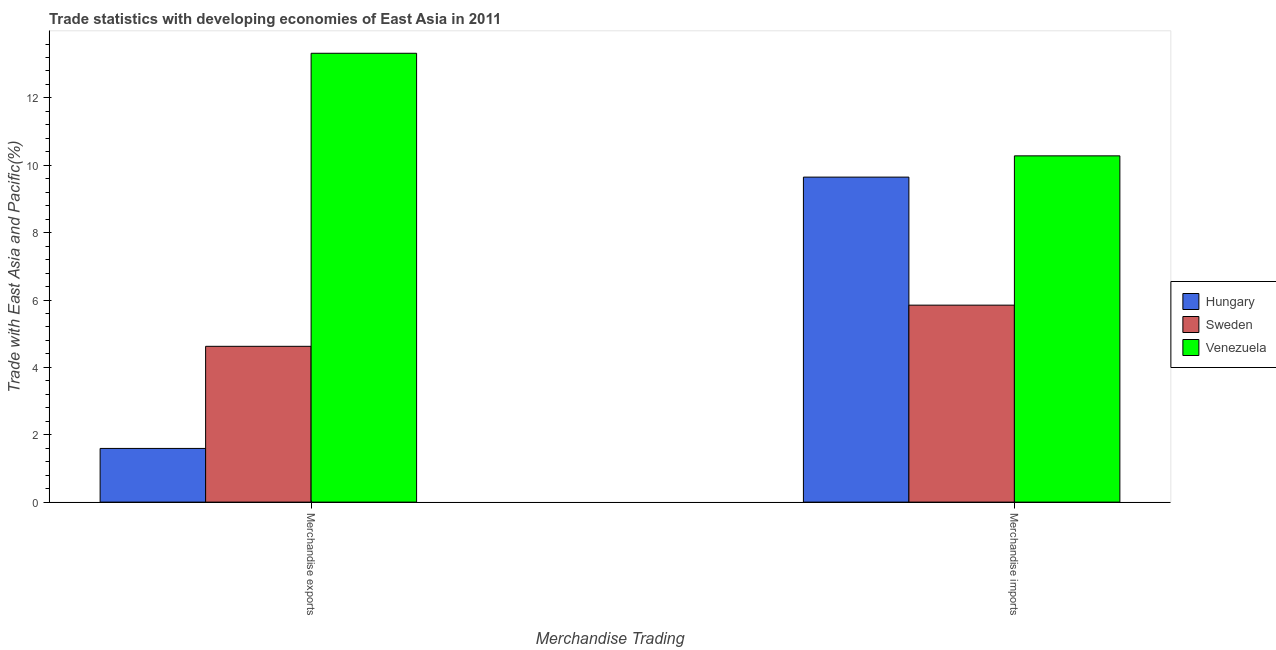How many different coloured bars are there?
Offer a very short reply. 3. Are the number of bars per tick equal to the number of legend labels?
Make the answer very short. Yes. Are the number of bars on each tick of the X-axis equal?
Offer a very short reply. Yes. How many bars are there on the 2nd tick from the left?
Offer a terse response. 3. What is the merchandise exports in Venezuela?
Provide a succinct answer. 13.33. Across all countries, what is the maximum merchandise imports?
Provide a short and direct response. 10.28. Across all countries, what is the minimum merchandise imports?
Provide a short and direct response. 5.85. In which country was the merchandise exports maximum?
Your answer should be compact. Venezuela. In which country was the merchandise exports minimum?
Provide a succinct answer. Hungary. What is the total merchandise exports in the graph?
Your answer should be very brief. 19.55. What is the difference between the merchandise exports in Sweden and that in Venezuela?
Offer a terse response. -8.7. What is the difference between the merchandise imports in Sweden and the merchandise exports in Hungary?
Offer a terse response. 4.25. What is the average merchandise imports per country?
Provide a short and direct response. 8.59. What is the difference between the merchandise exports and merchandise imports in Venezuela?
Give a very brief answer. 3.05. In how many countries, is the merchandise imports greater than 11.6 %?
Provide a short and direct response. 0. What is the ratio of the merchandise exports in Venezuela to that in Sweden?
Offer a terse response. 2.88. Is the merchandise imports in Sweden less than that in Hungary?
Your answer should be very brief. Yes. What does the 3rd bar from the left in Merchandise exports represents?
Your answer should be very brief. Venezuela. How many bars are there?
Give a very brief answer. 6. Are all the bars in the graph horizontal?
Offer a very short reply. No. How many countries are there in the graph?
Give a very brief answer. 3. What is the difference between two consecutive major ticks on the Y-axis?
Your answer should be very brief. 2. Are the values on the major ticks of Y-axis written in scientific E-notation?
Keep it short and to the point. No. Does the graph contain any zero values?
Give a very brief answer. No. Does the graph contain grids?
Provide a short and direct response. No. Where does the legend appear in the graph?
Your answer should be very brief. Center right. What is the title of the graph?
Offer a very short reply. Trade statistics with developing economies of East Asia in 2011. Does "Hungary" appear as one of the legend labels in the graph?
Make the answer very short. Yes. What is the label or title of the X-axis?
Give a very brief answer. Merchandise Trading. What is the label or title of the Y-axis?
Provide a succinct answer. Trade with East Asia and Pacific(%). What is the Trade with East Asia and Pacific(%) in Hungary in Merchandise exports?
Provide a short and direct response. 1.59. What is the Trade with East Asia and Pacific(%) in Sweden in Merchandise exports?
Your answer should be very brief. 4.63. What is the Trade with East Asia and Pacific(%) of Venezuela in Merchandise exports?
Offer a very short reply. 13.33. What is the Trade with East Asia and Pacific(%) of Hungary in Merchandise imports?
Ensure brevity in your answer.  9.65. What is the Trade with East Asia and Pacific(%) of Sweden in Merchandise imports?
Your answer should be very brief. 5.85. What is the Trade with East Asia and Pacific(%) of Venezuela in Merchandise imports?
Provide a short and direct response. 10.28. Across all Merchandise Trading, what is the maximum Trade with East Asia and Pacific(%) in Hungary?
Make the answer very short. 9.65. Across all Merchandise Trading, what is the maximum Trade with East Asia and Pacific(%) of Sweden?
Provide a succinct answer. 5.85. Across all Merchandise Trading, what is the maximum Trade with East Asia and Pacific(%) in Venezuela?
Your answer should be compact. 13.33. Across all Merchandise Trading, what is the minimum Trade with East Asia and Pacific(%) of Hungary?
Ensure brevity in your answer.  1.59. Across all Merchandise Trading, what is the minimum Trade with East Asia and Pacific(%) in Sweden?
Provide a short and direct response. 4.63. Across all Merchandise Trading, what is the minimum Trade with East Asia and Pacific(%) in Venezuela?
Your answer should be compact. 10.28. What is the total Trade with East Asia and Pacific(%) in Hungary in the graph?
Give a very brief answer. 11.24. What is the total Trade with East Asia and Pacific(%) in Sweden in the graph?
Provide a succinct answer. 10.47. What is the total Trade with East Asia and Pacific(%) of Venezuela in the graph?
Provide a succinct answer. 23.61. What is the difference between the Trade with East Asia and Pacific(%) in Hungary in Merchandise exports and that in Merchandise imports?
Keep it short and to the point. -8.06. What is the difference between the Trade with East Asia and Pacific(%) of Sweden in Merchandise exports and that in Merchandise imports?
Ensure brevity in your answer.  -1.22. What is the difference between the Trade with East Asia and Pacific(%) of Venezuela in Merchandise exports and that in Merchandise imports?
Your response must be concise. 3.05. What is the difference between the Trade with East Asia and Pacific(%) of Hungary in Merchandise exports and the Trade with East Asia and Pacific(%) of Sweden in Merchandise imports?
Keep it short and to the point. -4.25. What is the difference between the Trade with East Asia and Pacific(%) of Hungary in Merchandise exports and the Trade with East Asia and Pacific(%) of Venezuela in Merchandise imports?
Keep it short and to the point. -8.69. What is the difference between the Trade with East Asia and Pacific(%) in Sweden in Merchandise exports and the Trade with East Asia and Pacific(%) in Venezuela in Merchandise imports?
Your answer should be very brief. -5.65. What is the average Trade with East Asia and Pacific(%) in Hungary per Merchandise Trading?
Offer a very short reply. 5.62. What is the average Trade with East Asia and Pacific(%) in Sweden per Merchandise Trading?
Ensure brevity in your answer.  5.24. What is the average Trade with East Asia and Pacific(%) in Venezuela per Merchandise Trading?
Provide a short and direct response. 11.8. What is the difference between the Trade with East Asia and Pacific(%) in Hungary and Trade with East Asia and Pacific(%) in Sweden in Merchandise exports?
Your answer should be very brief. -3.03. What is the difference between the Trade with East Asia and Pacific(%) in Hungary and Trade with East Asia and Pacific(%) in Venezuela in Merchandise exports?
Your response must be concise. -11.73. What is the difference between the Trade with East Asia and Pacific(%) in Sweden and Trade with East Asia and Pacific(%) in Venezuela in Merchandise exports?
Keep it short and to the point. -8.7. What is the difference between the Trade with East Asia and Pacific(%) of Hungary and Trade with East Asia and Pacific(%) of Sweden in Merchandise imports?
Keep it short and to the point. 3.8. What is the difference between the Trade with East Asia and Pacific(%) of Hungary and Trade with East Asia and Pacific(%) of Venezuela in Merchandise imports?
Your response must be concise. -0.63. What is the difference between the Trade with East Asia and Pacific(%) of Sweden and Trade with East Asia and Pacific(%) of Venezuela in Merchandise imports?
Ensure brevity in your answer.  -4.43. What is the ratio of the Trade with East Asia and Pacific(%) of Hungary in Merchandise exports to that in Merchandise imports?
Your answer should be very brief. 0.17. What is the ratio of the Trade with East Asia and Pacific(%) of Sweden in Merchandise exports to that in Merchandise imports?
Offer a terse response. 0.79. What is the ratio of the Trade with East Asia and Pacific(%) in Venezuela in Merchandise exports to that in Merchandise imports?
Your answer should be compact. 1.3. What is the difference between the highest and the second highest Trade with East Asia and Pacific(%) in Hungary?
Make the answer very short. 8.06. What is the difference between the highest and the second highest Trade with East Asia and Pacific(%) in Sweden?
Provide a succinct answer. 1.22. What is the difference between the highest and the second highest Trade with East Asia and Pacific(%) in Venezuela?
Provide a short and direct response. 3.05. What is the difference between the highest and the lowest Trade with East Asia and Pacific(%) of Hungary?
Make the answer very short. 8.06. What is the difference between the highest and the lowest Trade with East Asia and Pacific(%) in Sweden?
Your answer should be very brief. 1.22. What is the difference between the highest and the lowest Trade with East Asia and Pacific(%) in Venezuela?
Offer a very short reply. 3.05. 